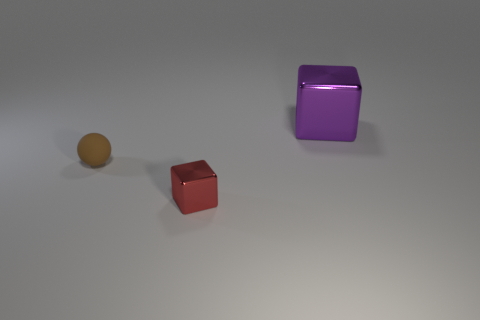Add 2 small metal blocks. How many objects exist? 5 Subtract all blocks. How many objects are left? 1 Subtract all metallic cylinders. Subtract all small spheres. How many objects are left? 2 Add 2 brown matte objects. How many brown matte objects are left? 3 Add 2 big metallic things. How many big metallic things exist? 3 Subtract 0 red cylinders. How many objects are left? 3 